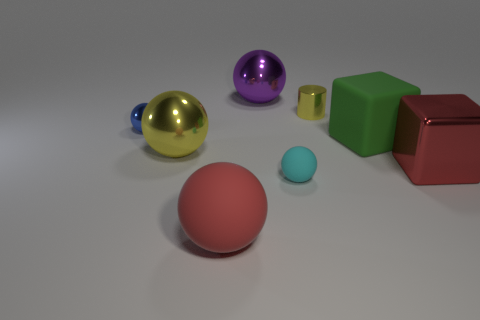The metal ball that is the same color as the shiny cylinder is what size?
Provide a succinct answer. Large. Is the number of large cubes less than the number of big balls?
Provide a succinct answer. Yes. There is a big sphere that is in front of the large red block; does it have the same color as the metallic cube?
Your answer should be compact. Yes. How many cyan matte spheres are the same size as the green matte block?
Provide a succinct answer. 0. Is there a ball that has the same color as the shiny block?
Your response must be concise. Yes. Is the big purple sphere made of the same material as the small cylinder?
Provide a succinct answer. Yes. What number of other large objects have the same shape as the cyan rubber object?
Offer a terse response. 3. What shape is the green thing that is made of the same material as the tiny cyan thing?
Provide a short and direct response. Cube. The small object left of the yellow object that is to the left of the red matte thing is what color?
Ensure brevity in your answer.  Blue. Is the metal cube the same color as the big matte ball?
Your answer should be very brief. Yes. 